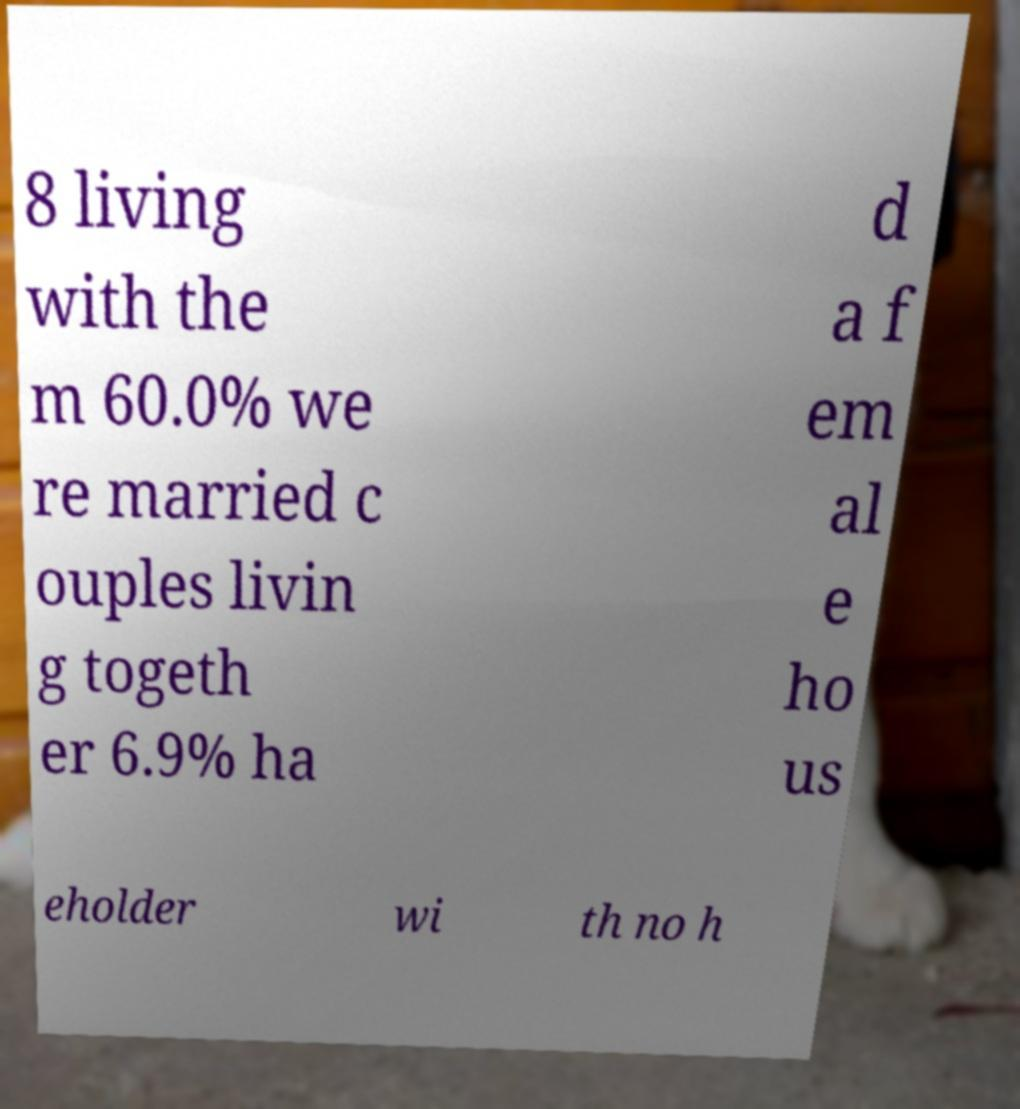What messages or text are displayed in this image? I need them in a readable, typed format. 8 living with the m 60.0% we re married c ouples livin g togeth er 6.9% ha d a f em al e ho us eholder wi th no h 